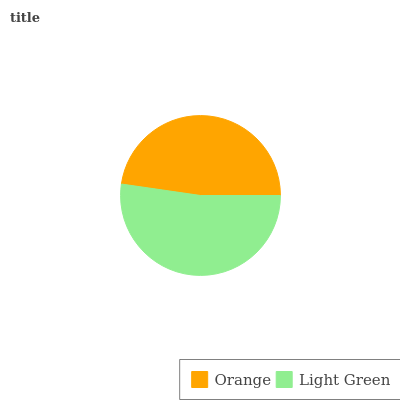Is Orange the minimum?
Answer yes or no. Yes. Is Light Green the maximum?
Answer yes or no. Yes. Is Light Green the minimum?
Answer yes or no. No. Is Light Green greater than Orange?
Answer yes or no. Yes. Is Orange less than Light Green?
Answer yes or no. Yes. Is Orange greater than Light Green?
Answer yes or no. No. Is Light Green less than Orange?
Answer yes or no. No. Is Light Green the high median?
Answer yes or no. Yes. Is Orange the low median?
Answer yes or no. Yes. Is Orange the high median?
Answer yes or no. No. Is Light Green the low median?
Answer yes or no. No. 